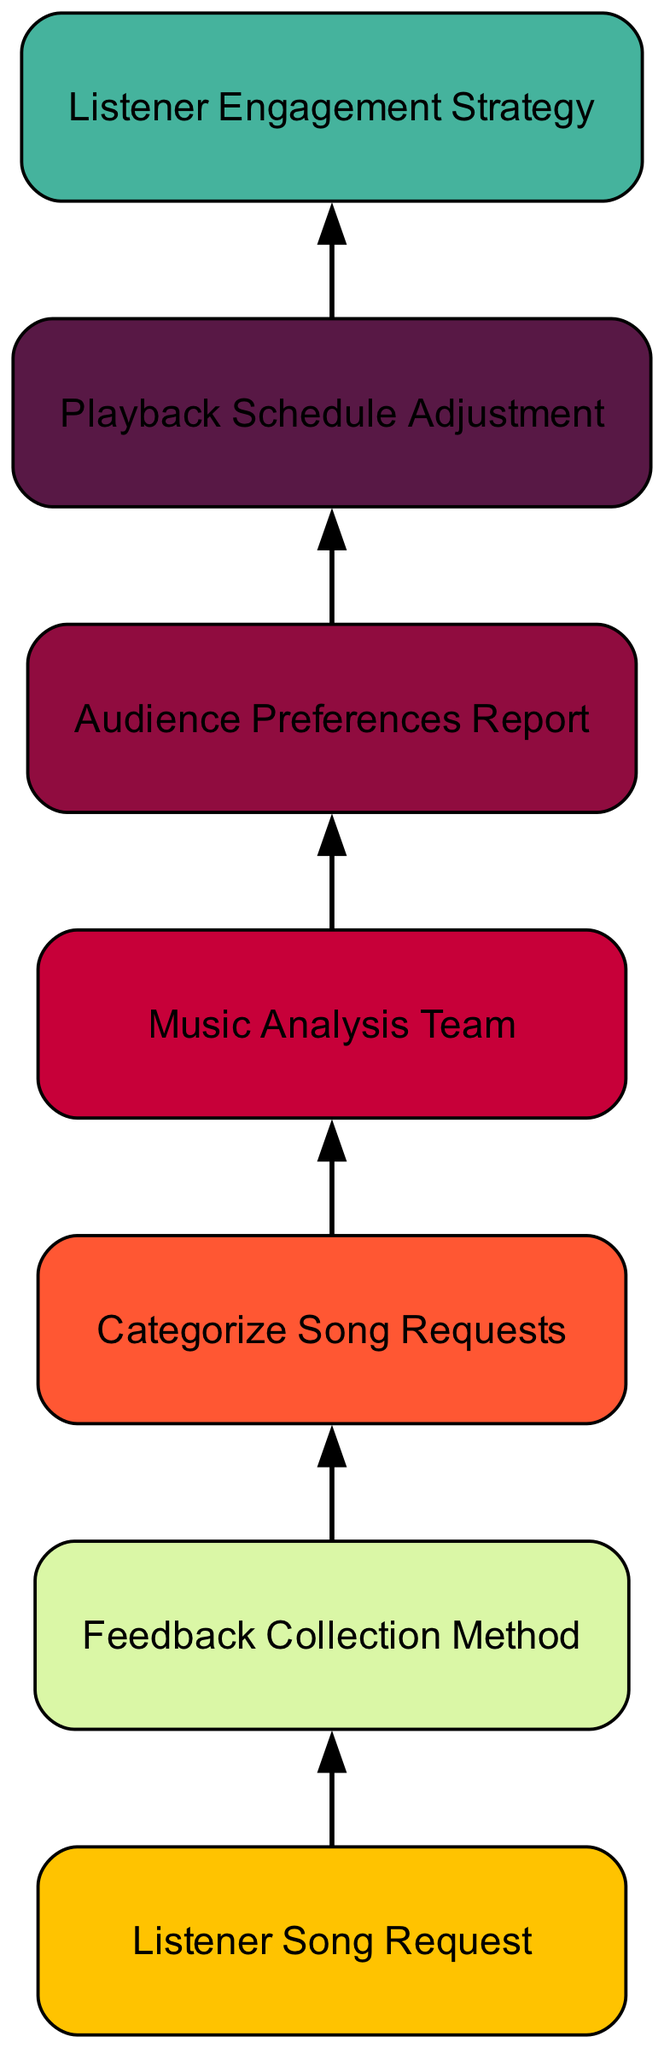What is the first step in the listener feedback process? The first node in the diagram is "Listener Song Request," which indicates that listeners start the process by submitting their requests for classic songs.
Answer: Listener Song Request How many nodes are there in the diagram? By counting all the distinct elements represented as nodes in the diagram, we identify a total of seven nodes: Listener Song Request, Feedback Collection Method, Categorize Song Requests, Music Analysis Team, Audience Preferences Report, Playback Schedule Adjustment, and Listener Engagement Strategy.
Answer: Seven What method is used to collect listener feedback? The node "Feedback Collection Method," indicates that listener feedback is collected through various means such as web forms, phone calls, or social media polls.
Answer: Feedback Collection Method What role does the Music Analysis Team play in the diagram? The "Music Analysis Team" processes categorized song requests and analyzes trends in those requests, which indicates its responsibility in the overall feedback process.
Answer: Music Analysis Team How does the Audience Preferences Report affect the Playback Schedule Adjustment? The "Audience Preferences Report" provides insights on the most requested songs and audience interests, which are then used to inform adjustments in the playback schedule, ensuring that popular requests are played.
Answer: Audience Preferences Report What follows after the Categorize Song Requests step? After the "Categorize Song Requests," the next step in the flow chart is to involve the "Music Analysis Team," meaning that categorized requests are taken for analysis at this point.
Answer: Music Analysis Team What is the purpose of the Listener Engagement Strategy? The node "Listener Engagement Strategy" illustrates that it aims to engage listeners by promoting new playlists based on requests, indicating its role in enhancing listener involvement.
Answer: Listener Engagement Strategy Which step directly leads to generating reports on audience trends? The step "Music Analysis Team" leads directly to the "Audience Preferences Report," as the team analyzes the requests to generate these reports.
Answer: Audience Preferences Report What is the ultimate goal of this listener feedback process? The final node, "Listener Engagement Strategy," signifies the overarching aim of the process, which is to better engage listeners through informed playlist adjustments based on their requests.
Answer: Listener Engagement Strategy 